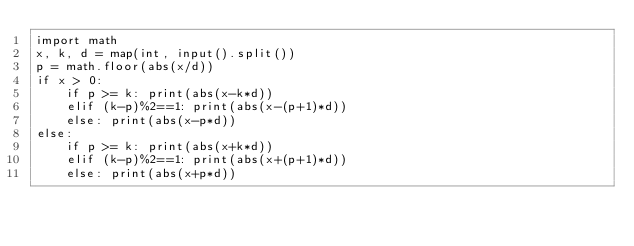<code> <loc_0><loc_0><loc_500><loc_500><_Python_>import math
x, k, d = map(int, input().split())
p = math.floor(abs(x/d))
if x > 0:
    if p >= k: print(abs(x-k*d))
    elif (k-p)%2==1: print(abs(x-(p+1)*d))
    else: print(abs(x-p*d))
else:
    if p >= k: print(abs(x+k*d))
    elif (k-p)%2==1: print(abs(x+(p+1)*d))
    else: print(abs(x+p*d))
</code> 